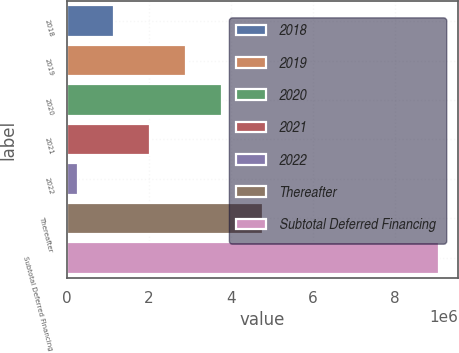<chart> <loc_0><loc_0><loc_500><loc_500><bar_chart><fcel>2018<fcel>2019<fcel>2020<fcel>2021<fcel>2022<fcel>Thereafter<fcel>Subtotal Deferred Financing<nl><fcel>1.14627e+06<fcel>2.90734e+06<fcel>3.78787e+06<fcel>2.02681e+06<fcel>265741<fcel>4.77623e+06<fcel>9.07107e+06<nl></chart> 